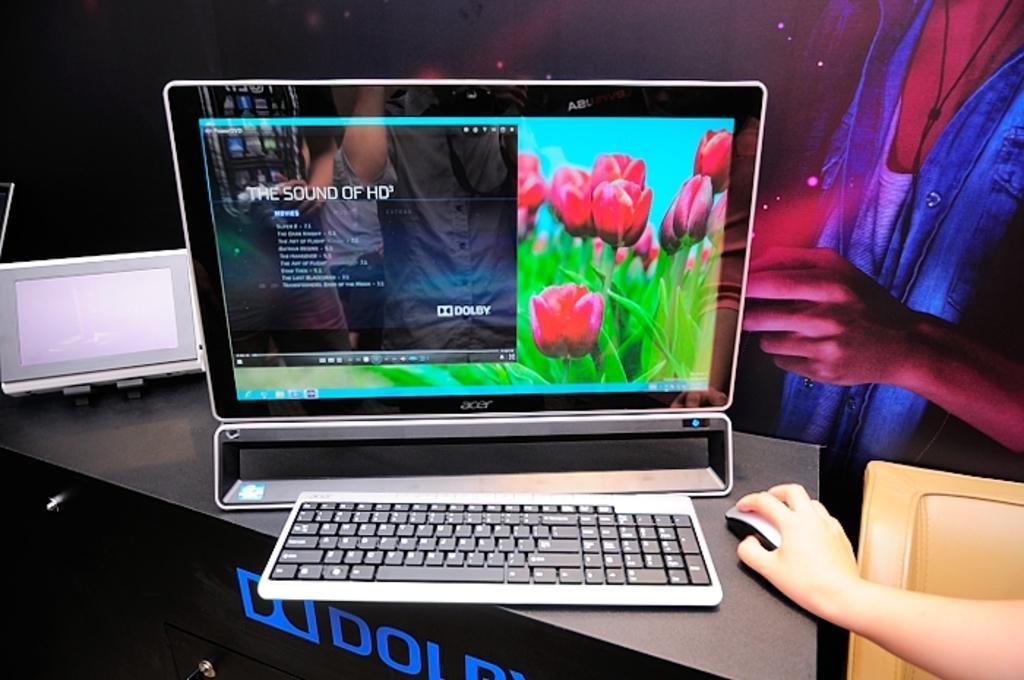Can you describe this image briefly? In this image we can see a monitor, keyboard and a mouse on the table, there is the hand of the person on the mouse, there is a board with an image on it, also we can see the reflection of a person on the monitor screen, there are flowers on the wallpaper of the monitor, there are text on the table, also we can see an electronic gadget on the table. 